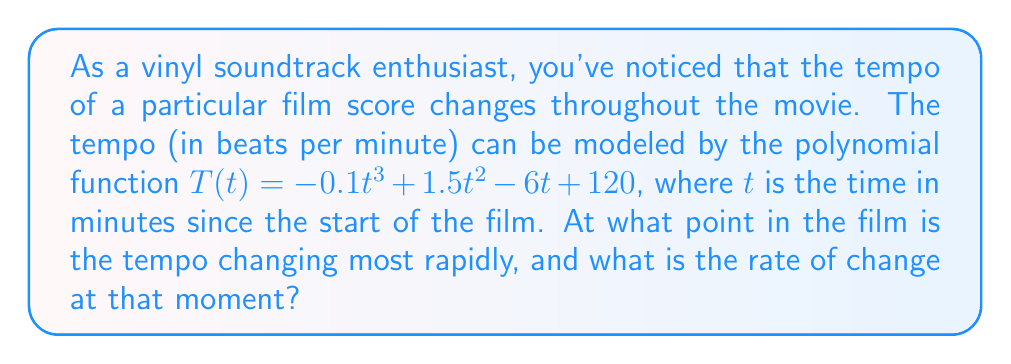Provide a solution to this math problem. To solve this problem, we need to follow these steps:

1) The rate of change of the tempo is given by the first derivative of $T(t)$. Let's call this $T'(t)$:

   $T'(t) = -0.3t^2 + 3t - 6$

2) To find where the tempo is changing most rapidly, we need to find the maximum absolute value of $T'(t)$. This occurs either at the extrema of $T'(t)$ or at the endpoints of the domain.

3) To find the extrema of $T'(t)$, we set its derivative equal to zero:

   $T''(t) = -0.6t + 3 = 0$
   $-0.6t = -3$
   $t = 5$

4) Now we need to check the value of $T'(t)$ at $t=5$ and at the endpoints of the domain. Since time can't be negative and movies typically don't last more than a few hours, let's consider the domain as $[0, 180]$ (3 hours).

   At $t=0$: $T'(0) = -6$
   At $t=5$: $T'(5) = -0.3(25) + 3(5) - 6 = -7.5 + 15 - 6 = 1.5$
   At $t=180$: $T'(180) = -0.3(180^2) + 3(180) - 6 = -9720 + 540 - 6 = -9186$

5) The largest absolute value among these is 9186, which occurs at $t=180$.

Therefore, the tempo is changing most rapidly at 180 minutes (3 hours) into the film, and the rate of change at that moment is -9186 beats per minute per minute.
Answer: The tempo is changing most rapidly at 180 minutes into the film, with a rate of change of -9186 beats per minute per minute. 